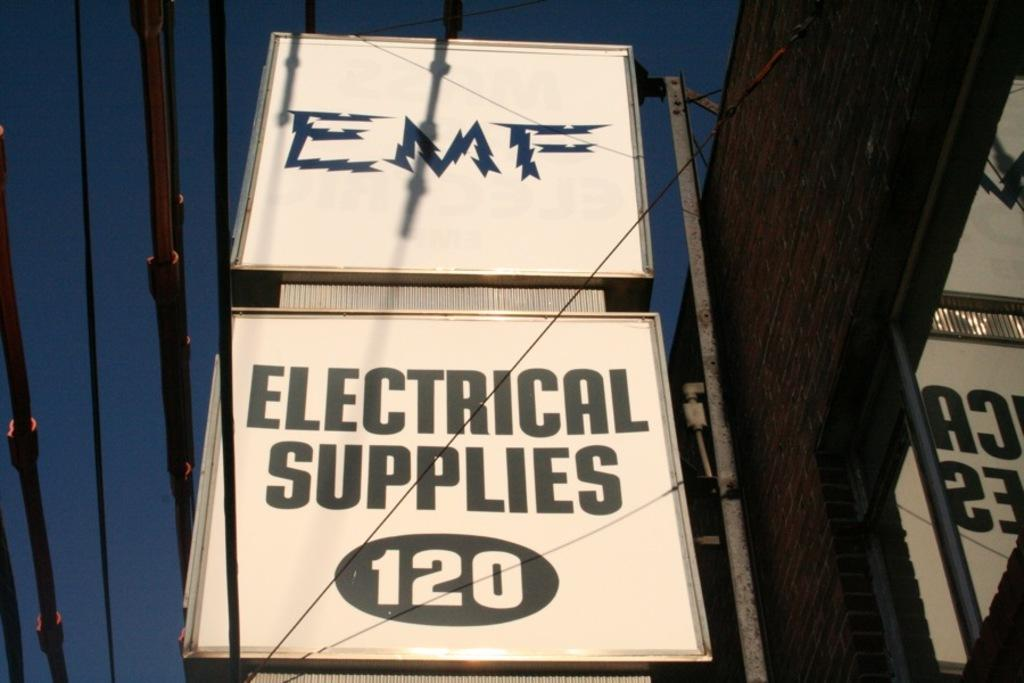Provide a one-sentence caption for the provided image. a sign that reads EMF Electical supplies 120. 